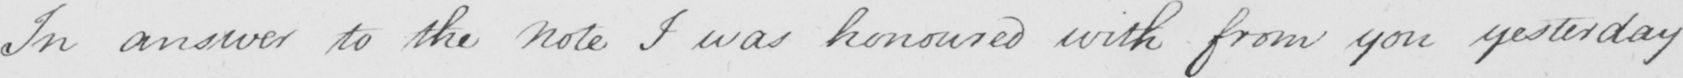Can you read and transcribe this handwriting? In answer to the Note I was honoured with from you yesterday 